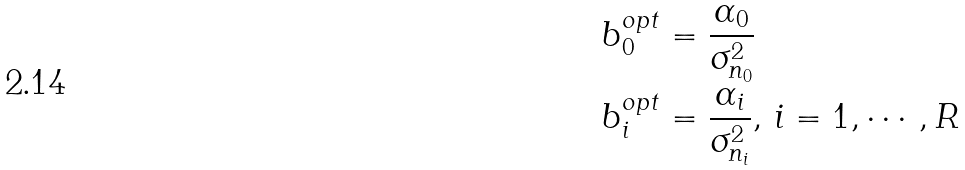<formula> <loc_0><loc_0><loc_500><loc_500>b _ { 0 } ^ { o p t } & = \frac { \alpha _ { 0 } } { \sigma _ { n _ { 0 } } ^ { 2 } } \\ b _ { i } ^ { o p t } & = \frac { \alpha _ { i } } { \sigma _ { n _ { i } } ^ { 2 } } , \, i = 1 , \cdots , R</formula> 